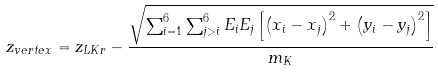Convert formula to latex. <formula><loc_0><loc_0><loc_500><loc_500>z _ { v e r t e x } = z _ { L K r } - \frac { \sqrt { \sum ^ { 6 } _ { i = 1 } \sum ^ { 6 } _ { j > i } E _ { i } E _ { j } \left [ \left ( x _ { i } - x _ { j } \right ) ^ { 2 } + \left ( y _ { i } - y _ { j } \right ) ^ { 2 } \right ] } } { m _ { K } }</formula> 